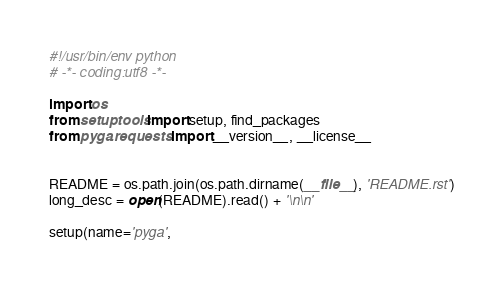<code> <loc_0><loc_0><loc_500><loc_500><_Python_>#!/usr/bin/env python
# -*- coding:utf8 -*-

import os
from setuptools import setup, find_packages
from pyga.requests import __version__, __license__


README = os.path.join(os.path.dirname(__file__), 'README.rst')
long_desc = open(README).read() + '\n\n'

setup(name='pyga',</code> 